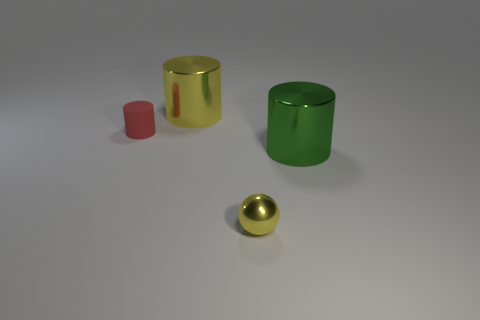There is a cylinder that is to the left of the tiny yellow sphere and in front of the large yellow cylinder; what is it made of?
Give a very brief answer. Rubber. What is the shape of the large object that is behind the large cylinder in front of the red object?
Your answer should be compact. Cylinder. Does the matte cylinder have the same color as the sphere?
Provide a short and direct response. No. How many green things are either things or tiny blocks?
Offer a terse response. 1. There is a big green shiny thing; are there any small yellow shiny balls on the right side of it?
Offer a terse response. No. What size is the rubber cylinder?
Offer a terse response. Small. There is another rubber thing that is the same shape as the large green object; what is its size?
Offer a very short reply. Small. What number of big green things are in front of the big metal thing that is to the left of the large green object?
Ensure brevity in your answer.  1. Are the large thing that is in front of the matte cylinder and the small object on the right side of the red object made of the same material?
Your answer should be very brief. Yes. What number of other red things are the same shape as the rubber object?
Provide a succinct answer. 0. 